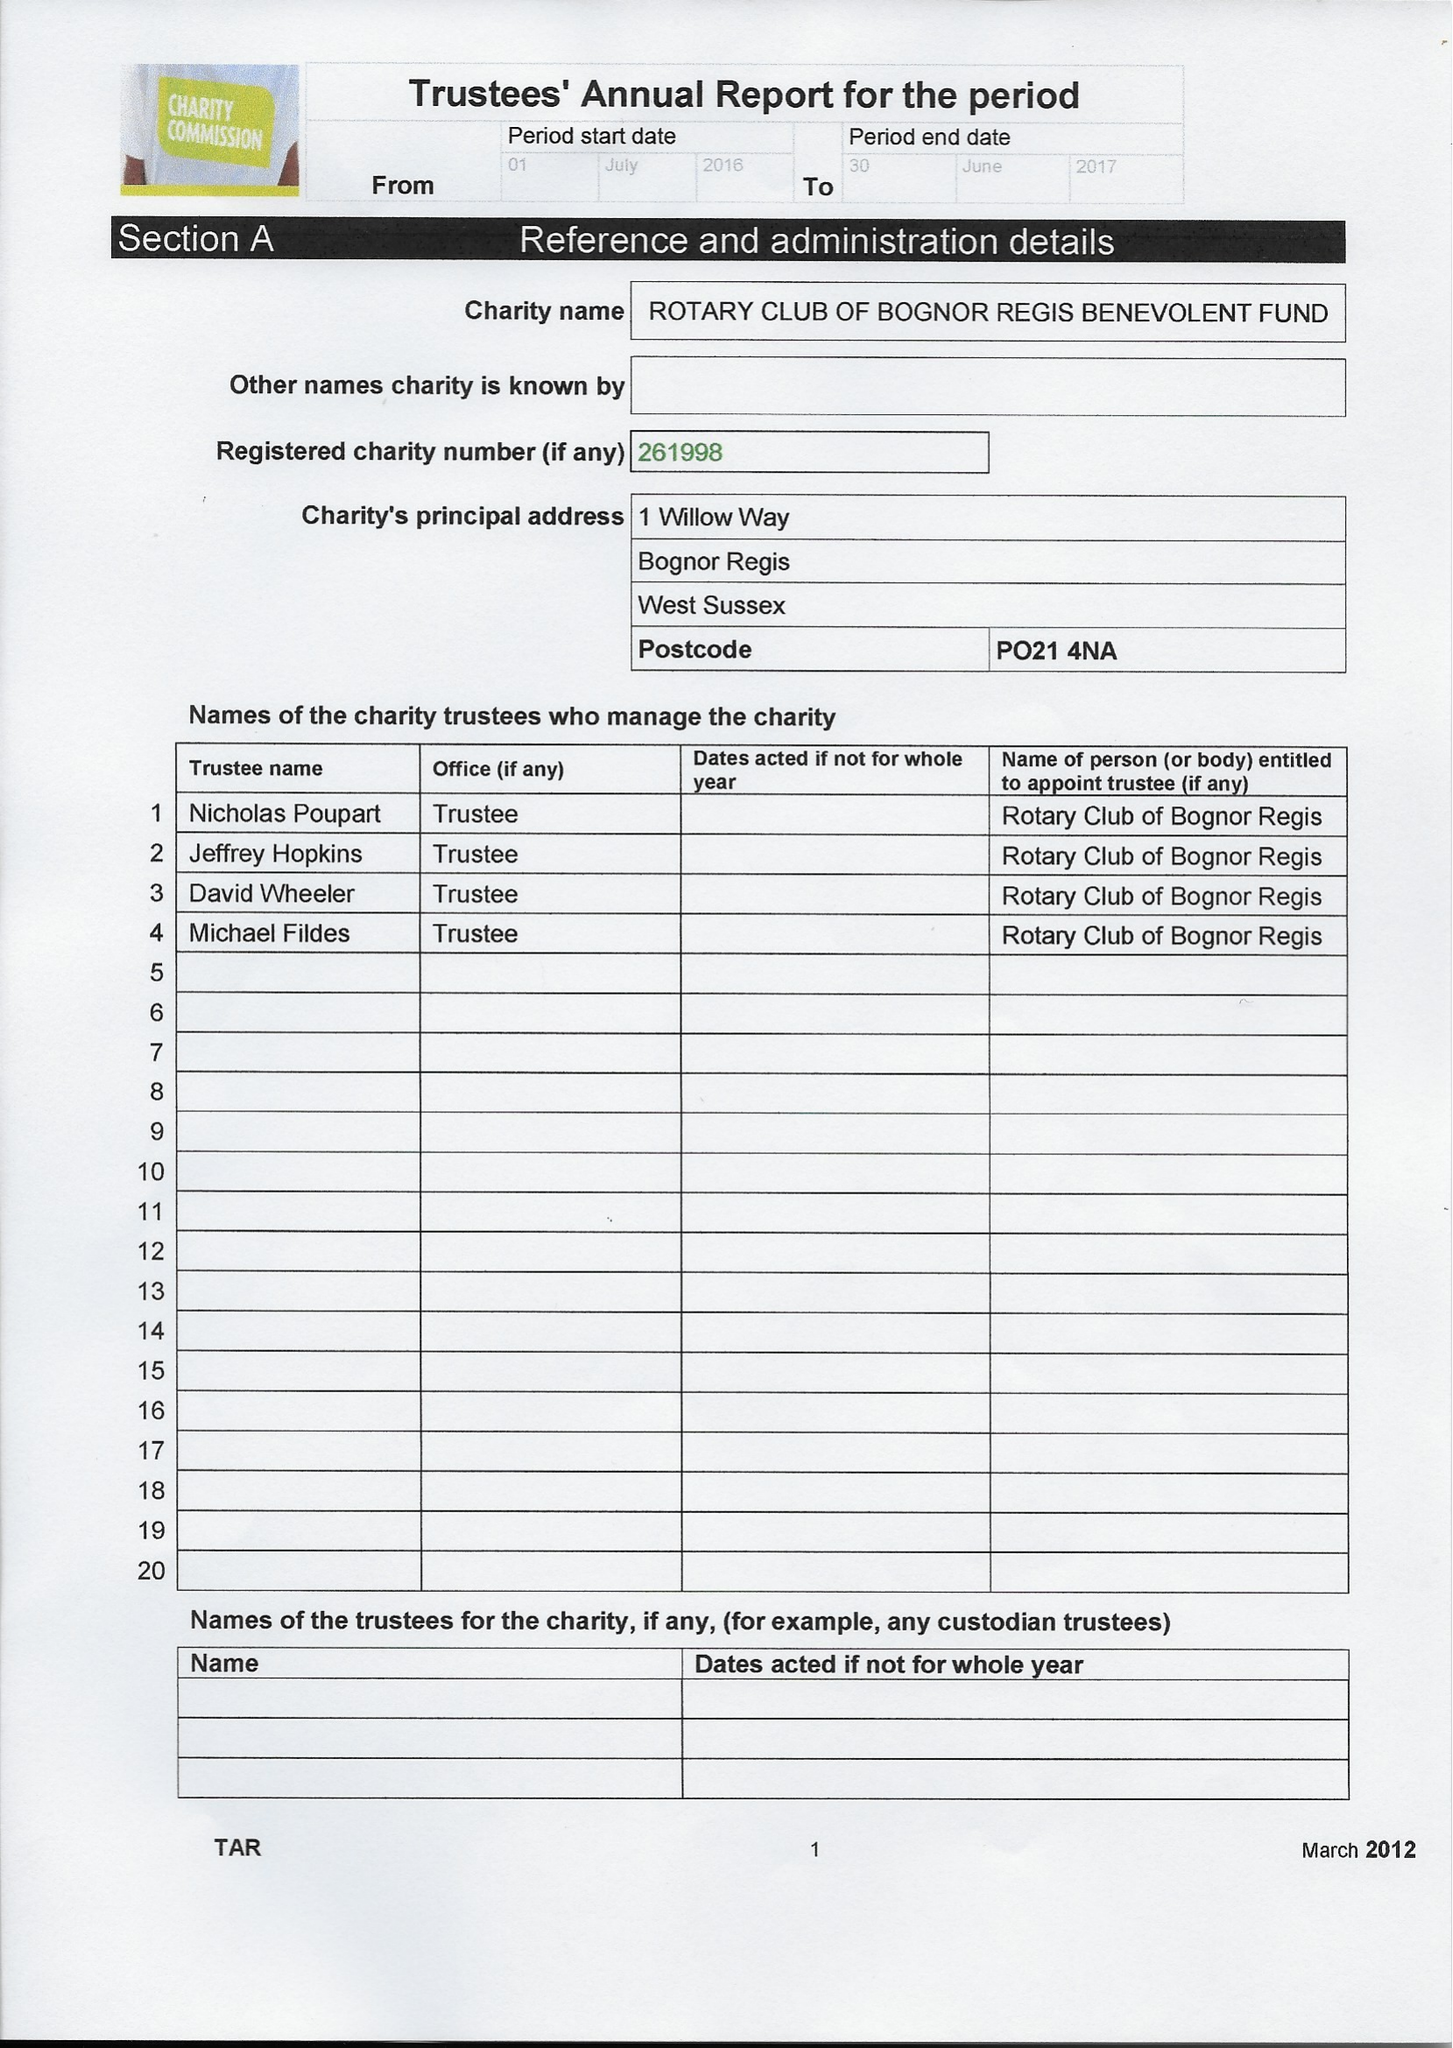What is the value for the address__post_town?
Answer the question using a single word or phrase. BOGNOR REGIS 